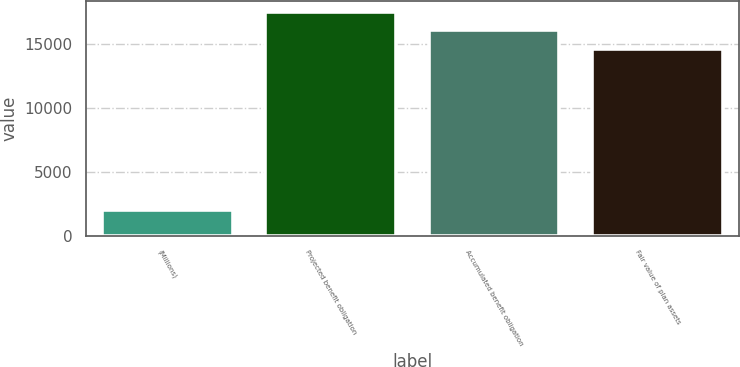Convert chart. <chart><loc_0><loc_0><loc_500><loc_500><bar_chart><fcel>(Millions)<fcel>Projected benefit obligation<fcel>Accumulated benefit obligation<fcel>Fair value of plan assets<nl><fcel>2014<fcel>17507.2<fcel>16065.1<fcel>14623<nl></chart> 